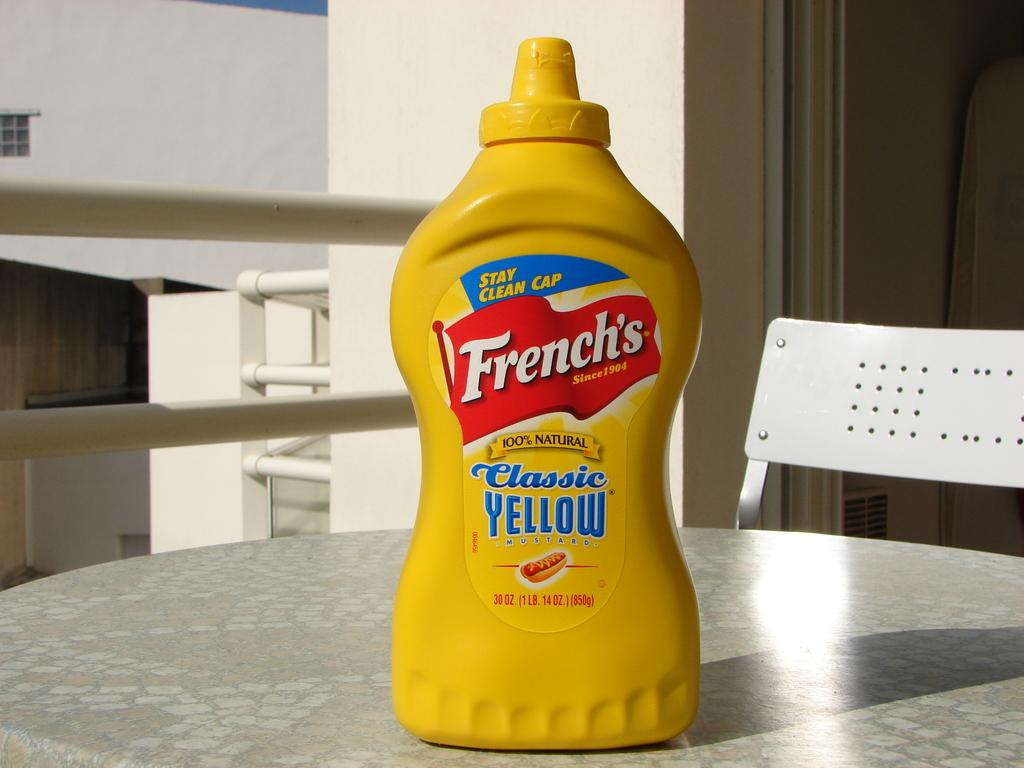<image>
Give a short and clear explanation of the subsequent image. Yellow bottle of French's yellow mustard sitting on a table top. 